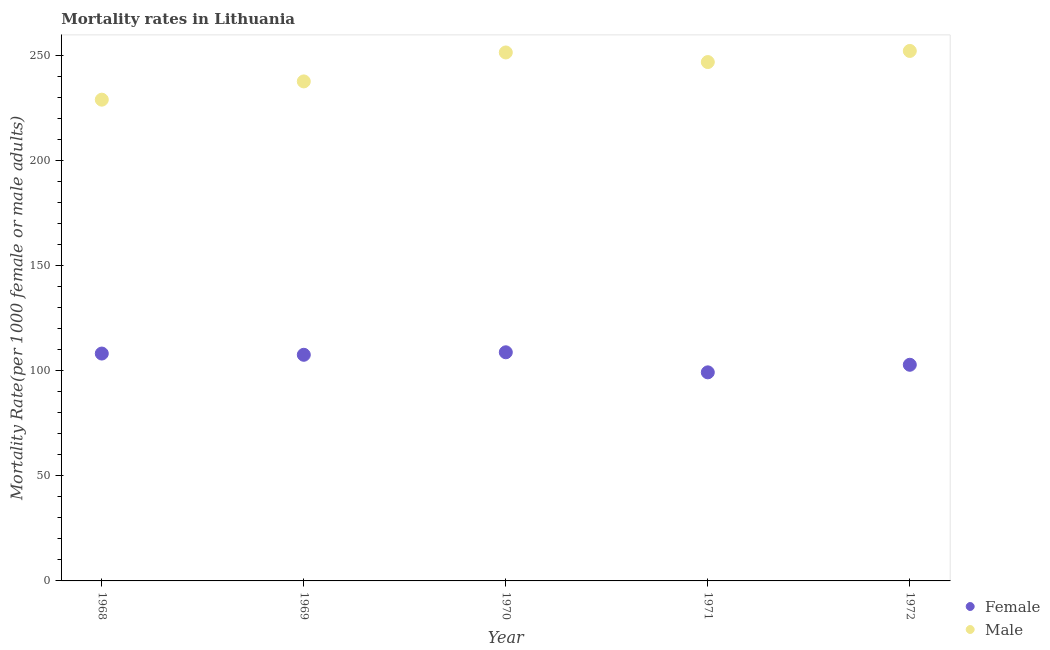How many different coloured dotlines are there?
Your response must be concise. 2. What is the female mortality rate in 1970?
Your answer should be very brief. 108.7. Across all years, what is the maximum female mortality rate?
Your answer should be compact. 108.7. Across all years, what is the minimum female mortality rate?
Make the answer very short. 99.16. In which year was the female mortality rate minimum?
Offer a terse response. 1971. What is the total female mortality rate in the graph?
Ensure brevity in your answer.  526.23. What is the difference between the female mortality rate in 1970 and that in 1971?
Your response must be concise. 9.54. What is the difference between the female mortality rate in 1968 and the male mortality rate in 1971?
Ensure brevity in your answer.  -138.58. What is the average male mortality rate per year?
Ensure brevity in your answer.  243.24. In the year 1969, what is the difference between the male mortality rate and female mortality rate?
Offer a very short reply. 129.97. In how many years, is the male mortality rate greater than 210?
Your answer should be compact. 5. What is the ratio of the female mortality rate in 1968 to that in 1972?
Your answer should be very brief. 1.05. Is the male mortality rate in 1971 less than that in 1972?
Provide a succinct answer. Yes. Is the difference between the female mortality rate in 1969 and 1971 greater than the difference between the male mortality rate in 1969 and 1971?
Ensure brevity in your answer.  Yes. What is the difference between the highest and the second highest male mortality rate?
Ensure brevity in your answer.  0.72. What is the difference between the highest and the lowest male mortality rate?
Offer a terse response. 23.16. Does the female mortality rate monotonically increase over the years?
Provide a succinct answer. No. Is the male mortality rate strictly greater than the female mortality rate over the years?
Keep it short and to the point. Yes. How many years are there in the graph?
Your response must be concise. 5. How are the legend labels stacked?
Ensure brevity in your answer.  Vertical. What is the title of the graph?
Give a very brief answer. Mortality rates in Lithuania. What is the label or title of the Y-axis?
Give a very brief answer. Mortality Rate(per 1000 female or male adults). What is the Mortality Rate(per 1000 female or male adults) in Female in 1968?
Give a very brief answer. 108.1. What is the Mortality Rate(per 1000 female or male adults) of Male in 1968?
Offer a terse response. 228.81. What is the Mortality Rate(per 1000 female or male adults) in Female in 1969?
Your response must be concise. 107.51. What is the Mortality Rate(per 1000 female or male adults) of Male in 1969?
Give a very brief answer. 237.48. What is the Mortality Rate(per 1000 female or male adults) of Female in 1970?
Your response must be concise. 108.7. What is the Mortality Rate(per 1000 female or male adults) in Male in 1970?
Provide a short and direct response. 251.24. What is the Mortality Rate(per 1000 female or male adults) in Female in 1971?
Offer a very short reply. 99.16. What is the Mortality Rate(per 1000 female or male adults) of Male in 1971?
Offer a terse response. 246.68. What is the Mortality Rate(per 1000 female or male adults) in Female in 1972?
Provide a short and direct response. 102.76. What is the Mortality Rate(per 1000 female or male adults) in Male in 1972?
Ensure brevity in your answer.  251.97. Across all years, what is the maximum Mortality Rate(per 1000 female or male adults) of Female?
Provide a succinct answer. 108.7. Across all years, what is the maximum Mortality Rate(per 1000 female or male adults) in Male?
Your response must be concise. 251.97. Across all years, what is the minimum Mortality Rate(per 1000 female or male adults) in Female?
Your answer should be very brief. 99.16. Across all years, what is the minimum Mortality Rate(per 1000 female or male adults) of Male?
Your response must be concise. 228.81. What is the total Mortality Rate(per 1000 female or male adults) of Female in the graph?
Keep it short and to the point. 526.23. What is the total Mortality Rate(per 1000 female or male adults) in Male in the graph?
Your answer should be compact. 1216.18. What is the difference between the Mortality Rate(per 1000 female or male adults) of Female in 1968 and that in 1969?
Offer a very short reply. 0.59. What is the difference between the Mortality Rate(per 1000 female or male adults) in Male in 1968 and that in 1969?
Offer a very short reply. -8.68. What is the difference between the Mortality Rate(per 1000 female or male adults) in Female in 1968 and that in 1970?
Offer a very short reply. -0.6. What is the difference between the Mortality Rate(per 1000 female or male adults) of Male in 1968 and that in 1970?
Your answer should be compact. -22.44. What is the difference between the Mortality Rate(per 1000 female or male adults) of Female in 1968 and that in 1971?
Keep it short and to the point. 8.94. What is the difference between the Mortality Rate(per 1000 female or male adults) of Male in 1968 and that in 1971?
Your answer should be very brief. -17.88. What is the difference between the Mortality Rate(per 1000 female or male adults) in Female in 1968 and that in 1972?
Your answer should be compact. 5.34. What is the difference between the Mortality Rate(per 1000 female or male adults) of Male in 1968 and that in 1972?
Provide a succinct answer. -23.16. What is the difference between the Mortality Rate(per 1000 female or male adults) in Female in 1969 and that in 1970?
Ensure brevity in your answer.  -1.19. What is the difference between the Mortality Rate(per 1000 female or male adults) of Male in 1969 and that in 1970?
Offer a terse response. -13.76. What is the difference between the Mortality Rate(per 1000 female or male adults) in Female in 1969 and that in 1971?
Offer a very short reply. 8.35. What is the difference between the Mortality Rate(per 1000 female or male adults) of Male in 1969 and that in 1971?
Ensure brevity in your answer.  -9.2. What is the difference between the Mortality Rate(per 1000 female or male adults) of Female in 1969 and that in 1972?
Provide a short and direct response. 4.75. What is the difference between the Mortality Rate(per 1000 female or male adults) of Male in 1969 and that in 1972?
Give a very brief answer. -14.48. What is the difference between the Mortality Rate(per 1000 female or male adults) of Female in 1970 and that in 1971?
Offer a terse response. 9.54. What is the difference between the Mortality Rate(per 1000 female or male adults) of Male in 1970 and that in 1971?
Provide a succinct answer. 4.56. What is the difference between the Mortality Rate(per 1000 female or male adults) of Female in 1970 and that in 1972?
Keep it short and to the point. 5.94. What is the difference between the Mortality Rate(per 1000 female or male adults) of Male in 1970 and that in 1972?
Offer a terse response. -0.72. What is the difference between the Mortality Rate(per 1000 female or male adults) of Female in 1971 and that in 1972?
Your answer should be compact. -3.6. What is the difference between the Mortality Rate(per 1000 female or male adults) of Male in 1971 and that in 1972?
Offer a very short reply. -5.29. What is the difference between the Mortality Rate(per 1000 female or male adults) in Female in 1968 and the Mortality Rate(per 1000 female or male adults) in Male in 1969?
Provide a succinct answer. -129.38. What is the difference between the Mortality Rate(per 1000 female or male adults) in Female in 1968 and the Mortality Rate(per 1000 female or male adults) in Male in 1970?
Keep it short and to the point. -143.14. What is the difference between the Mortality Rate(per 1000 female or male adults) in Female in 1968 and the Mortality Rate(per 1000 female or male adults) in Male in 1971?
Provide a succinct answer. -138.58. What is the difference between the Mortality Rate(per 1000 female or male adults) in Female in 1968 and the Mortality Rate(per 1000 female or male adults) in Male in 1972?
Ensure brevity in your answer.  -143.87. What is the difference between the Mortality Rate(per 1000 female or male adults) in Female in 1969 and the Mortality Rate(per 1000 female or male adults) in Male in 1970?
Ensure brevity in your answer.  -143.73. What is the difference between the Mortality Rate(per 1000 female or male adults) in Female in 1969 and the Mortality Rate(per 1000 female or male adults) in Male in 1971?
Ensure brevity in your answer.  -139.17. What is the difference between the Mortality Rate(per 1000 female or male adults) of Female in 1969 and the Mortality Rate(per 1000 female or male adults) of Male in 1972?
Provide a succinct answer. -144.46. What is the difference between the Mortality Rate(per 1000 female or male adults) in Female in 1970 and the Mortality Rate(per 1000 female or male adults) in Male in 1971?
Provide a short and direct response. -137.98. What is the difference between the Mortality Rate(per 1000 female or male adults) in Female in 1970 and the Mortality Rate(per 1000 female or male adults) in Male in 1972?
Provide a succinct answer. -143.27. What is the difference between the Mortality Rate(per 1000 female or male adults) of Female in 1971 and the Mortality Rate(per 1000 female or male adults) of Male in 1972?
Make the answer very short. -152.81. What is the average Mortality Rate(per 1000 female or male adults) in Female per year?
Offer a terse response. 105.25. What is the average Mortality Rate(per 1000 female or male adults) in Male per year?
Provide a succinct answer. 243.24. In the year 1968, what is the difference between the Mortality Rate(per 1000 female or male adults) in Female and Mortality Rate(per 1000 female or male adults) in Male?
Your answer should be very brief. -120.71. In the year 1969, what is the difference between the Mortality Rate(per 1000 female or male adults) of Female and Mortality Rate(per 1000 female or male adults) of Male?
Your answer should be very brief. -129.97. In the year 1970, what is the difference between the Mortality Rate(per 1000 female or male adults) in Female and Mortality Rate(per 1000 female or male adults) in Male?
Ensure brevity in your answer.  -142.54. In the year 1971, what is the difference between the Mortality Rate(per 1000 female or male adults) in Female and Mortality Rate(per 1000 female or male adults) in Male?
Offer a very short reply. -147.52. In the year 1972, what is the difference between the Mortality Rate(per 1000 female or male adults) of Female and Mortality Rate(per 1000 female or male adults) of Male?
Your answer should be compact. -149.2. What is the ratio of the Mortality Rate(per 1000 female or male adults) in Male in 1968 to that in 1969?
Your answer should be compact. 0.96. What is the ratio of the Mortality Rate(per 1000 female or male adults) of Female in 1968 to that in 1970?
Make the answer very short. 0.99. What is the ratio of the Mortality Rate(per 1000 female or male adults) in Male in 1968 to that in 1970?
Offer a terse response. 0.91. What is the ratio of the Mortality Rate(per 1000 female or male adults) of Female in 1968 to that in 1971?
Offer a very short reply. 1.09. What is the ratio of the Mortality Rate(per 1000 female or male adults) of Male in 1968 to that in 1971?
Offer a very short reply. 0.93. What is the ratio of the Mortality Rate(per 1000 female or male adults) of Female in 1968 to that in 1972?
Offer a very short reply. 1.05. What is the ratio of the Mortality Rate(per 1000 female or male adults) of Male in 1968 to that in 1972?
Make the answer very short. 0.91. What is the ratio of the Mortality Rate(per 1000 female or male adults) in Male in 1969 to that in 1970?
Make the answer very short. 0.95. What is the ratio of the Mortality Rate(per 1000 female or male adults) of Female in 1969 to that in 1971?
Provide a succinct answer. 1.08. What is the ratio of the Mortality Rate(per 1000 female or male adults) of Male in 1969 to that in 1971?
Your answer should be very brief. 0.96. What is the ratio of the Mortality Rate(per 1000 female or male adults) of Female in 1969 to that in 1972?
Provide a short and direct response. 1.05. What is the ratio of the Mortality Rate(per 1000 female or male adults) of Male in 1969 to that in 1972?
Provide a succinct answer. 0.94. What is the ratio of the Mortality Rate(per 1000 female or male adults) in Female in 1970 to that in 1971?
Provide a short and direct response. 1.1. What is the ratio of the Mortality Rate(per 1000 female or male adults) in Male in 1970 to that in 1971?
Your response must be concise. 1.02. What is the ratio of the Mortality Rate(per 1000 female or male adults) in Female in 1970 to that in 1972?
Provide a short and direct response. 1.06. What is the ratio of the Mortality Rate(per 1000 female or male adults) of Male in 1970 to that in 1972?
Give a very brief answer. 1. What is the ratio of the Mortality Rate(per 1000 female or male adults) of Female in 1971 to that in 1972?
Give a very brief answer. 0.96. What is the difference between the highest and the second highest Mortality Rate(per 1000 female or male adults) of Female?
Keep it short and to the point. 0.6. What is the difference between the highest and the second highest Mortality Rate(per 1000 female or male adults) in Male?
Your answer should be very brief. 0.72. What is the difference between the highest and the lowest Mortality Rate(per 1000 female or male adults) in Female?
Offer a very short reply. 9.54. What is the difference between the highest and the lowest Mortality Rate(per 1000 female or male adults) of Male?
Your answer should be compact. 23.16. 